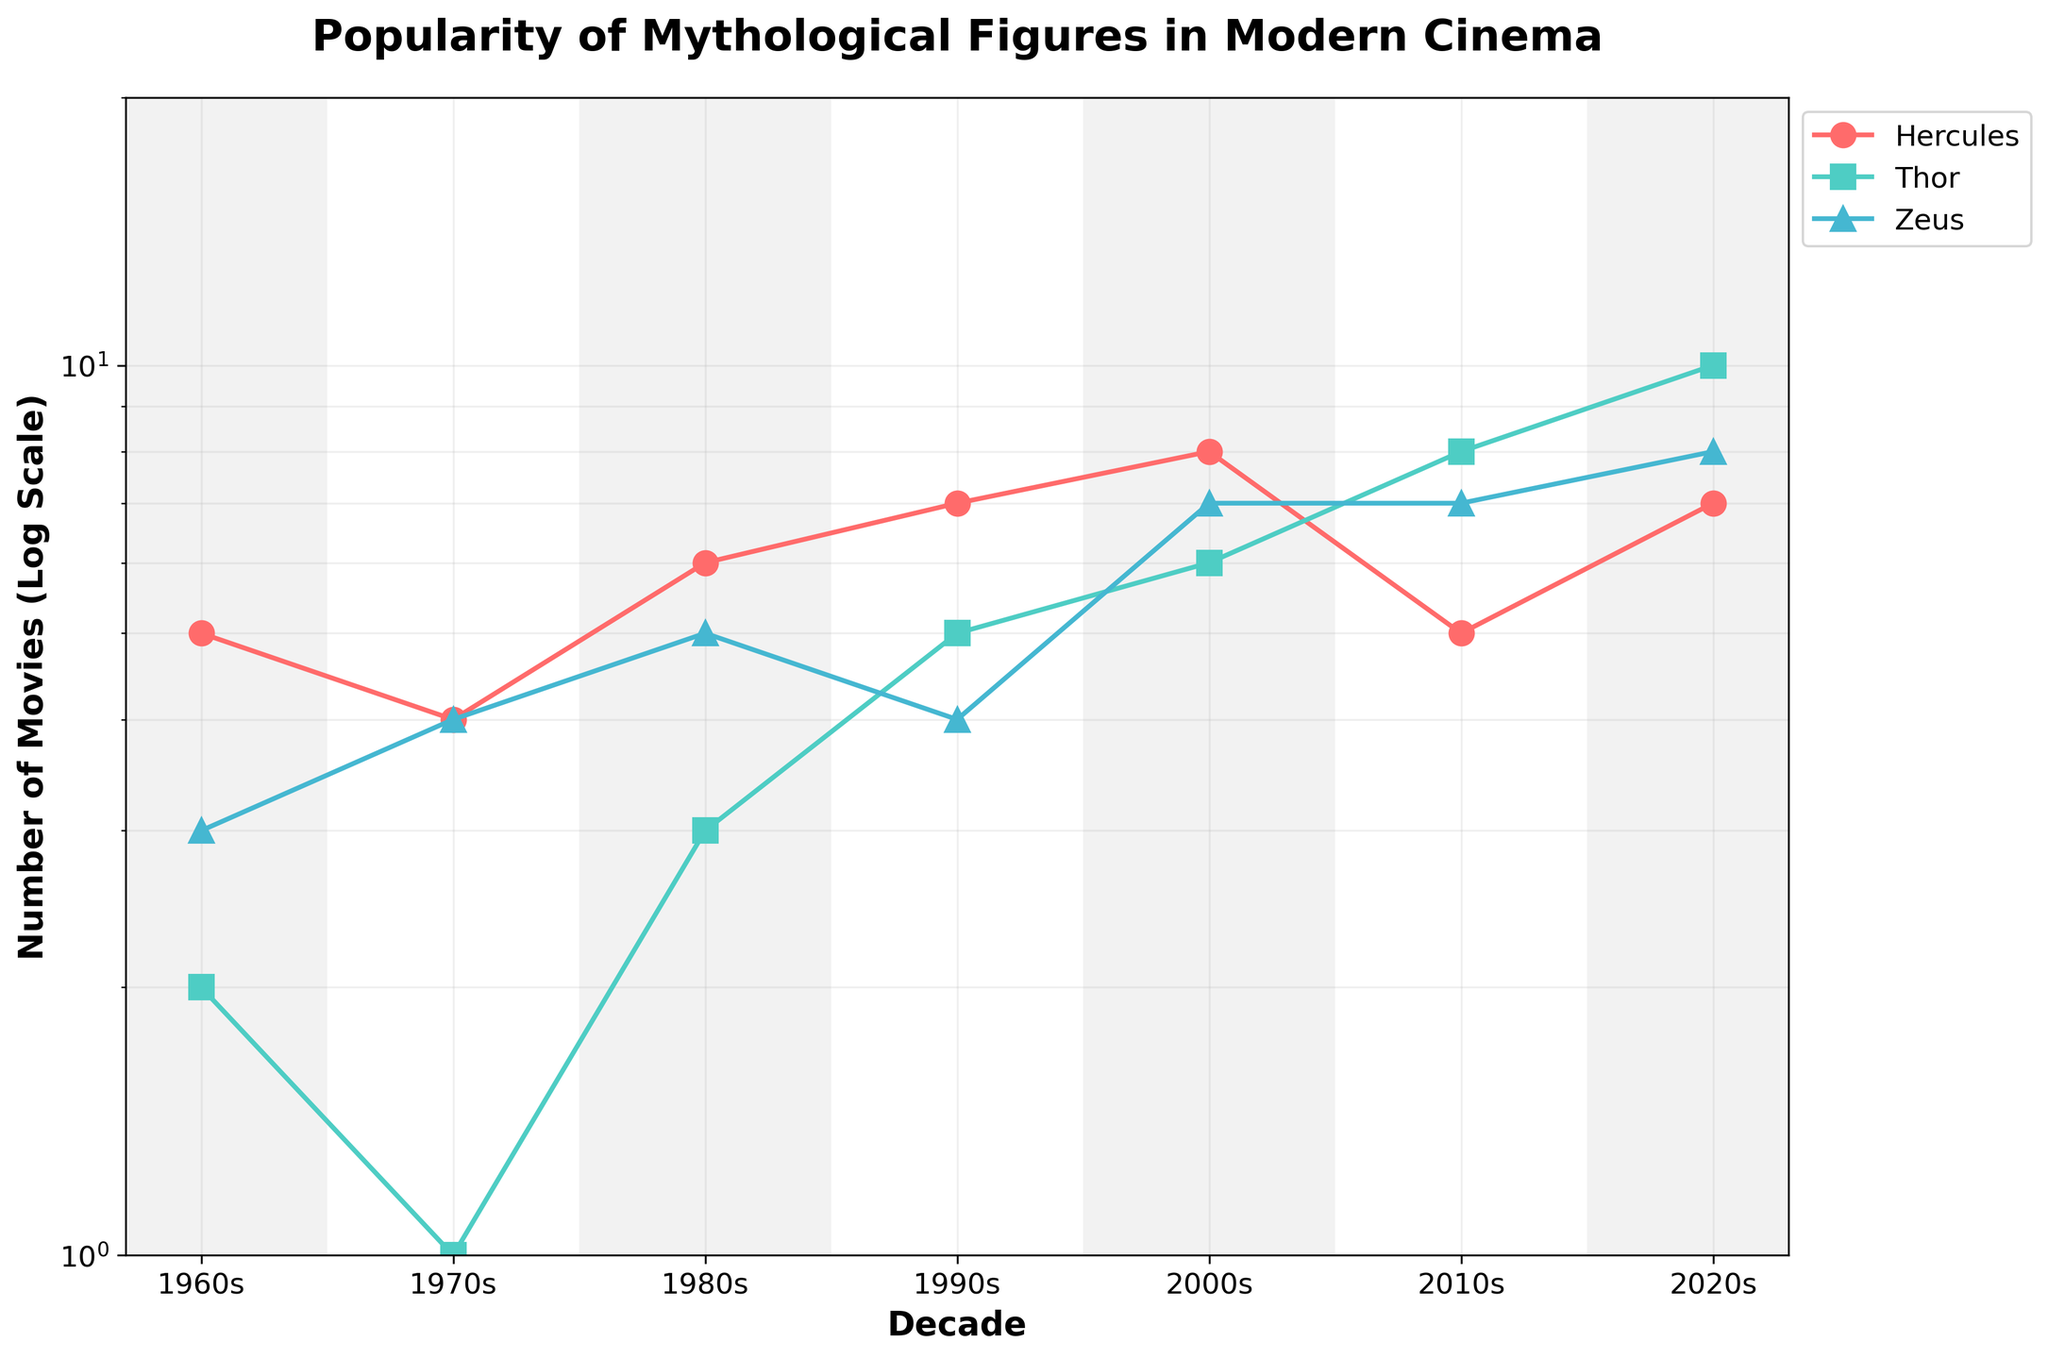what is the title of the plot? The title of the plot is prominently displayed at the top of the figure.
Answer: Popularity of Mythological Figures in Modern Cinema What does the y-axis represent? The y-axis represents the "Number of Movies." It is labeled as "Number of Movies (Log Scale)" indicating it uses a logarithmic scale.
Answer: Number of Movies (Log Scale) which mythological figure appears most frequently in movies in the 2020s? Observing the data points for the 2020s, Thor has the highest value.
Answer: Thor For which decade was Hercules featured in the most movies? By observing the trend line for Hercules across all decades, the peak value for the number of movies is 8 in the 2000s.
Answer: 2000s What's the difference in the number of movies featuring Thor between the 1980s and 2010s? The data points for Thor show 3 movies in the 1980s and 8 in the 2010s. The difference is 8 - 3 = 5.
Answer: 5 How many times does Zeus' number of movie appearances remain consistent over two consecutive decades? By examining the trend line for Zeus, the number of movie appearances remains the same between the 2000s and 2010s.
Answer: 1 Which mythological figure's popularity decreased in the 2010s compared to the 2000s? Analyzing the trend lines, Hercules' number of movie appearances decreased from 8 in the 2000s to 5 in the 2010s.
Answer: Hercules Comparing the 1960s and 2020s, which decade had more movies featuring Zeus? The data points for Zeus show 3 movies in the 1960s and 8 in the 2020s. Therefore, there are more movies in the 2020s.
Answer: 2020s What is the average number of movies featuring Thor across all decades? The number of movies for Thor are: 2, 1, 3, 5, 6, 8, 10. Sum these values: 2 + 1 + 3 + 5 + 6 + 8 + 10 = 35. There are 7 decades, so the average is 35/7 = 5.
Answer: 5 